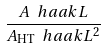Convert formula to latex. <formula><loc_0><loc_0><loc_500><loc_500>\frac { A \ h a a k { L } } { A _ { \text {HT} } \ h a a k { L } ^ { 2 } }</formula> 